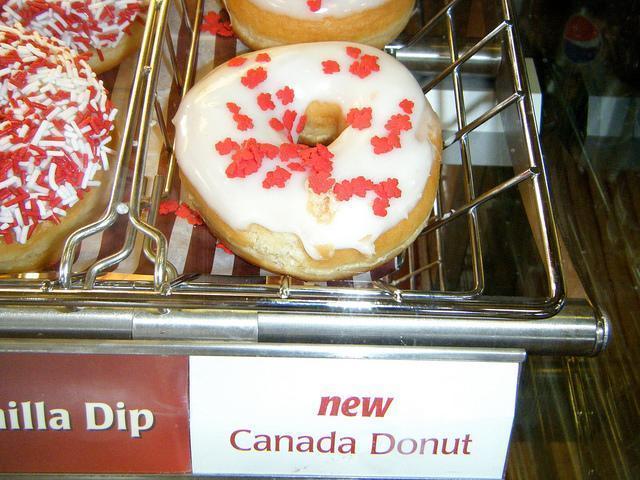How many donuts are visible?
Give a very brief answer. 4. How many clear bottles are there in the image?
Give a very brief answer. 0. 